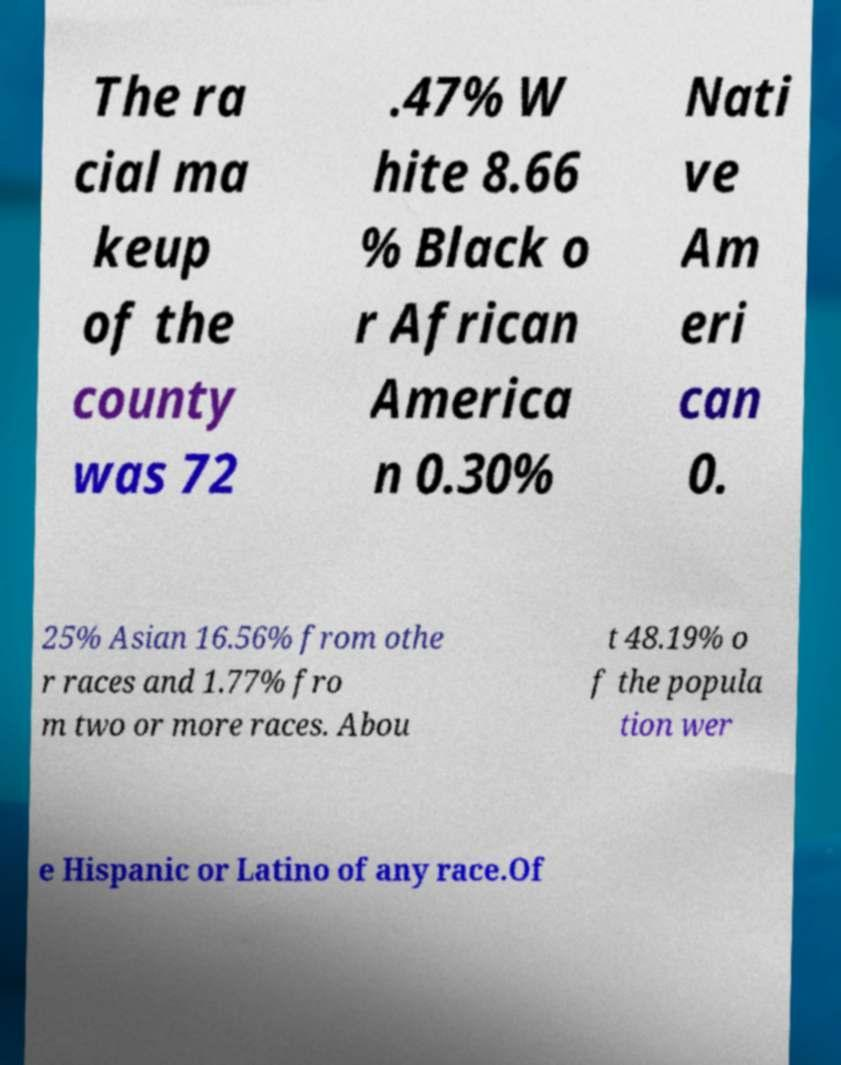What messages or text are displayed in this image? I need them in a readable, typed format. The ra cial ma keup of the county was 72 .47% W hite 8.66 % Black o r African America n 0.30% Nati ve Am eri can 0. 25% Asian 16.56% from othe r races and 1.77% fro m two or more races. Abou t 48.19% o f the popula tion wer e Hispanic or Latino of any race.Of 